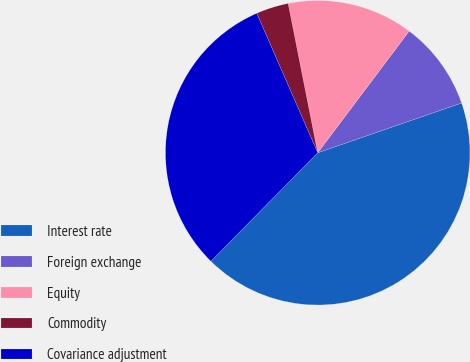Convert chart. <chart><loc_0><loc_0><loc_500><loc_500><pie_chart><fcel>Interest rate<fcel>Foreign exchange<fcel>Equity<fcel>Commodity<fcel>Covariance adjustment<nl><fcel>42.68%<fcel>9.44%<fcel>13.37%<fcel>3.45%<fcel>31.06%<nl></chart> 